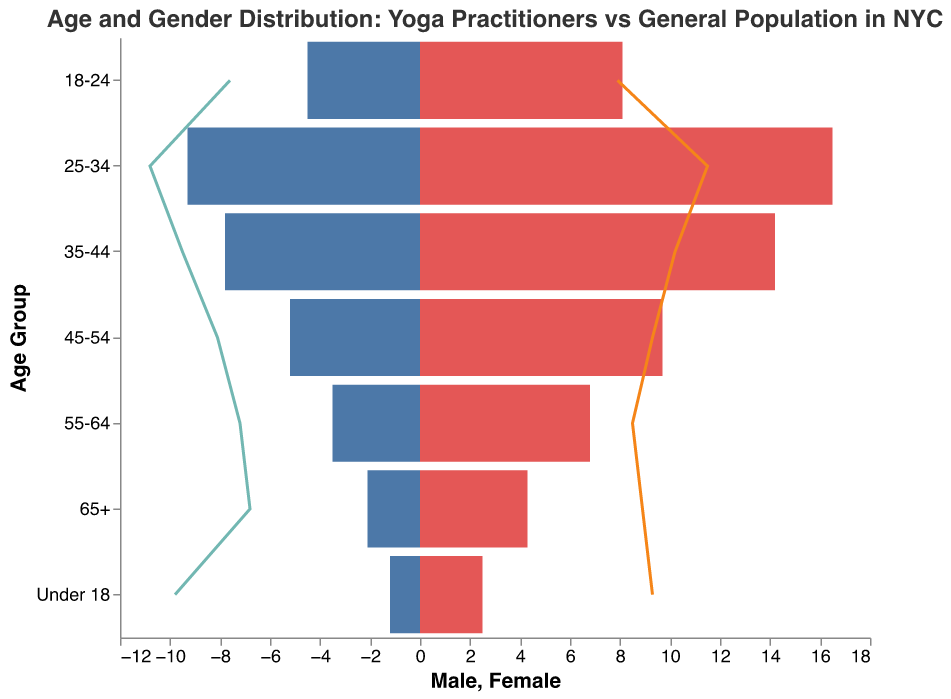What is the title of the figure? The title is usually located at the top of the figure and is in a larger font to highlight the main purpose of the figure.
Answer: Age and Gender Distribution: Yoga Practitioners vs General Population in NYC Which age group has the highest proportion of female yoga practitioners? By examining the bars corresponding to female yoga practitioners, the bar for the age group 25-34 is the longest, indicating the highest proportion.
Answer: 25-34 How does the proportion of male yoga practitioners in the 45-54 age group compare to the general male population in the same age group? When comparing the lengths of the bars for male yoga practitioners and the general male population in the 45-54 age group, the general male population bar is longer, indicating a higher proportion.
Answer: General male population is higher What is the pattern observed in the proportion of yoga practitioners under 18 compared to the general population? By comparing the lengths of the bars in the 'Under 18' age group, it's clear that both male and female yoga practitioners have significantly lower proportions compared to their counterparts in the general population.
Answer: Proportions are significantly lower for yoga practitioners What is the difference in the proportion of female yoga practitioners and female general population in the 25-34 age group? The proportion of female yoga practitioners is 16.5, and that of the general population is 11.5. Subtracting these values yields 5.
Answer: 5 Which gender has a higher proportion of yoga practitioners in the age group 35-44? By comparing the lengths of the bars for male and female yoga practitioners in the 35-44 age group, the female bar is longer.
Answer: Female What can you infer about the gender distribution of yoga practitioners in age 65+ compared to the general population? The lengths of the bars show that both male and female proportions of yoga practitioners are lower compared to their counterparts in the general population.
Answer: Lower for yoga practitioners Which age group shows the smallest difference between male and female yoga practitioners? By comparing the differences in the lengths of the bars between male and female yoga practitioners across all age groups, the smallest difference is observed in the 18-24 age group.
Answer: 18-24 In which age group does the proportion of male yoga practitioners exceed the female yoga practitioners? By examining the lengths of the bars for yoga practitioners across all age groups, no age group shows the male bar exceeding the female bar.
Answer: None What is the trend in the proportion of yoga practitioners as age increases from 18 to 65+? By looking at the yoga practitioner bars as age progresses from 18 to 65+, there is a general decrease in the male proportion and a less pronounced but similar trend in the female proportion.
Answer: General decrease 